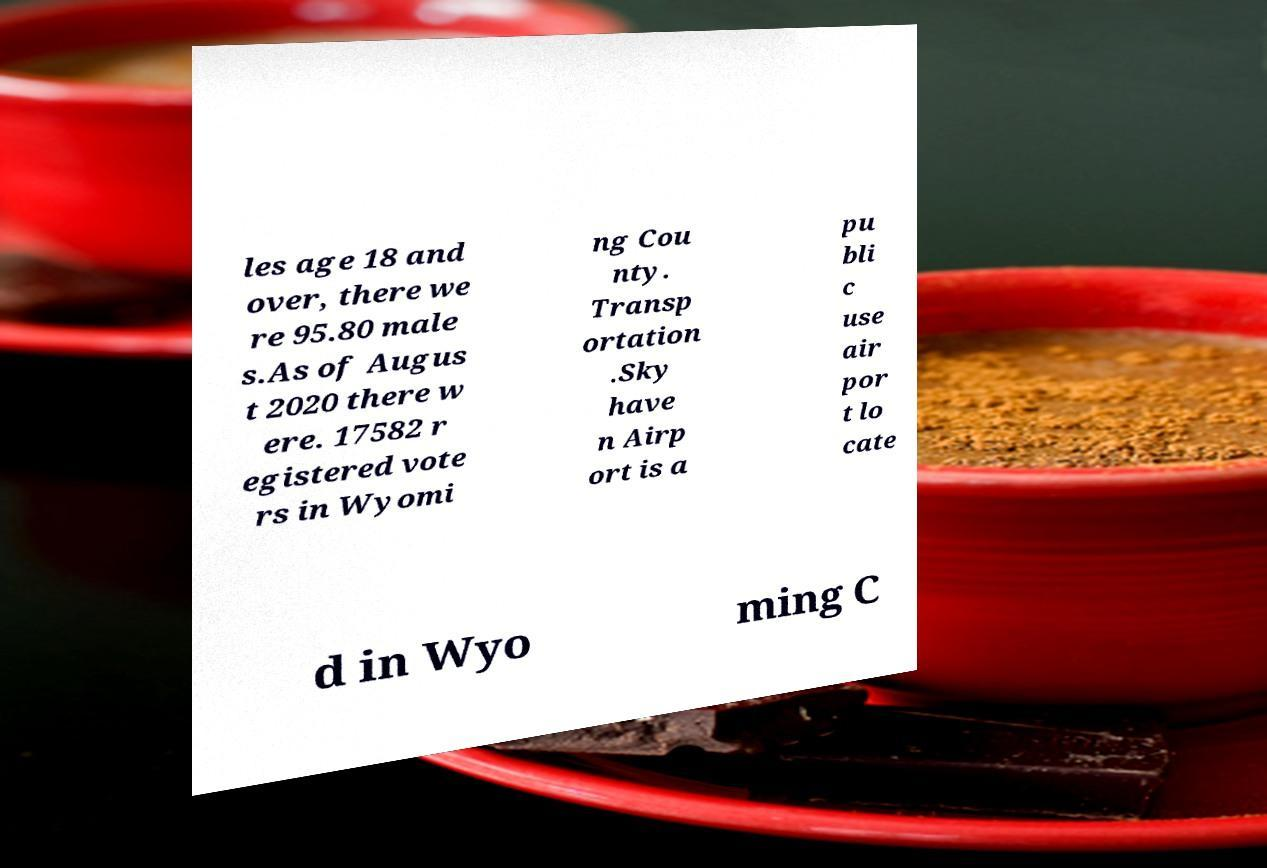Can you accurately transcribe the text from the provided image for me? les age 18 and over, there we re 95.80 male s.As of Augus t 2020 there w ere. 17582 r egistered vote rs in Wyomi ng Cou nty. Transp ortation .Sky have n Airp ort is a pu bli c use air por t lo cate d in Wyo ming C 